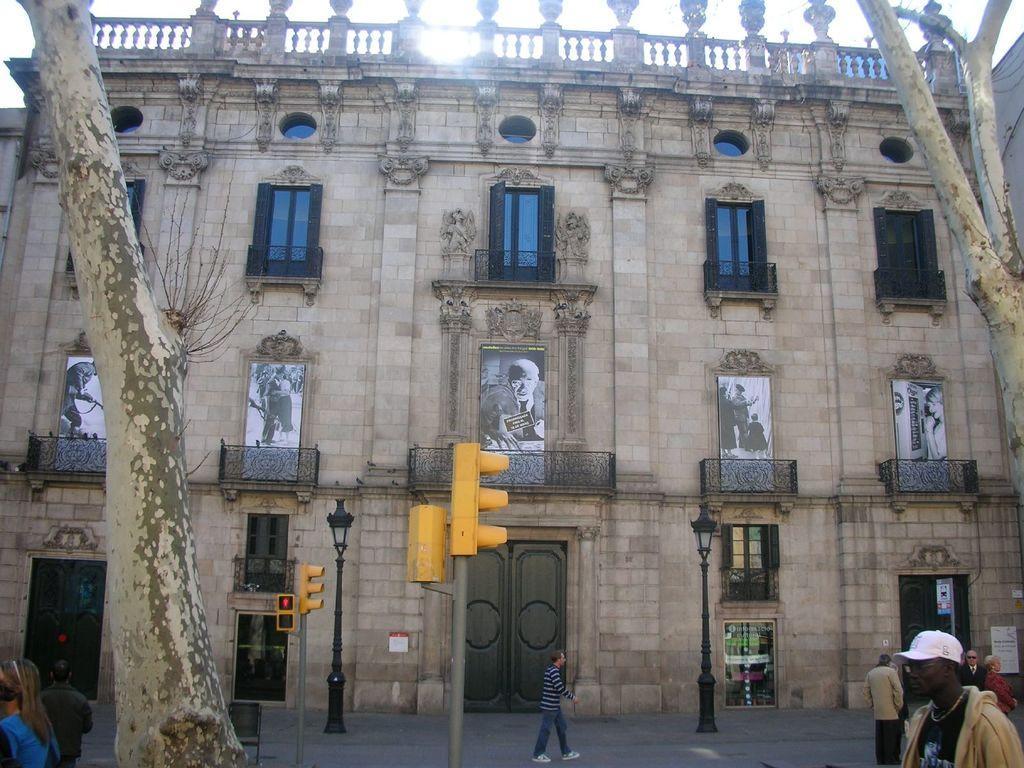How would you summarize this image in a sentence or two? This picture is clicked outside. On the right we can see the group of people. In the center there is a person walking on the ground. On the left we can see the two persons and we can see the trunks and branches of the trees. In the center there is a door and we can see the lamps attached to poles and traffic lights attached to the poles and we can see the building and the windows and doors of the building and we can see the pictures of some persons on the building. In the background there is a sky. 